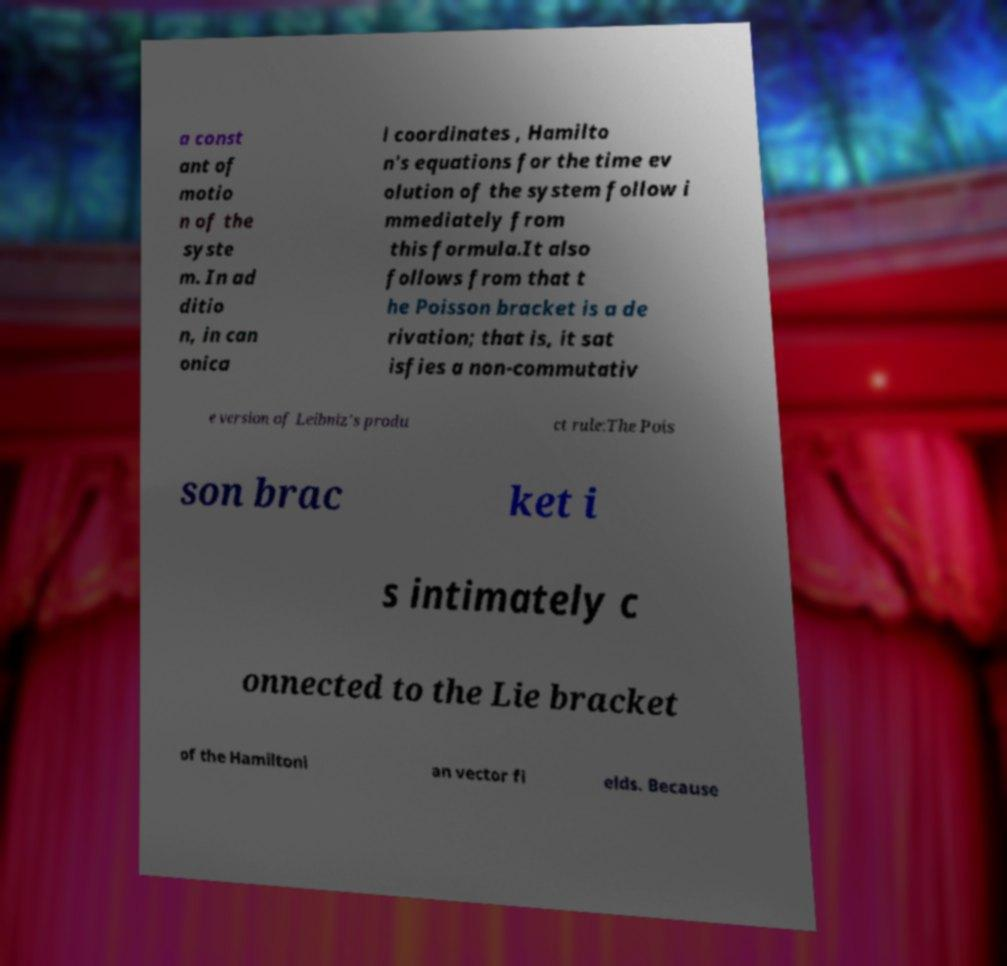Could you assist in decoding the text presented in this image and type it out clearly? a const ant of motio n of the syste m. In ad ditio n, in can onica l coordinates , Hamilto n's equations for the time ev olution of the system follow i mmediately from this formula.It also follows from that t he Poisson bracket is a de rivation; that is, it sat isfies a non-commutativ e version of Leibniz's produ ct rule:The Pois son brac ket i s intimately c onnected to the Lie bracket of the Hamiltoni an vector fi elds. Because 